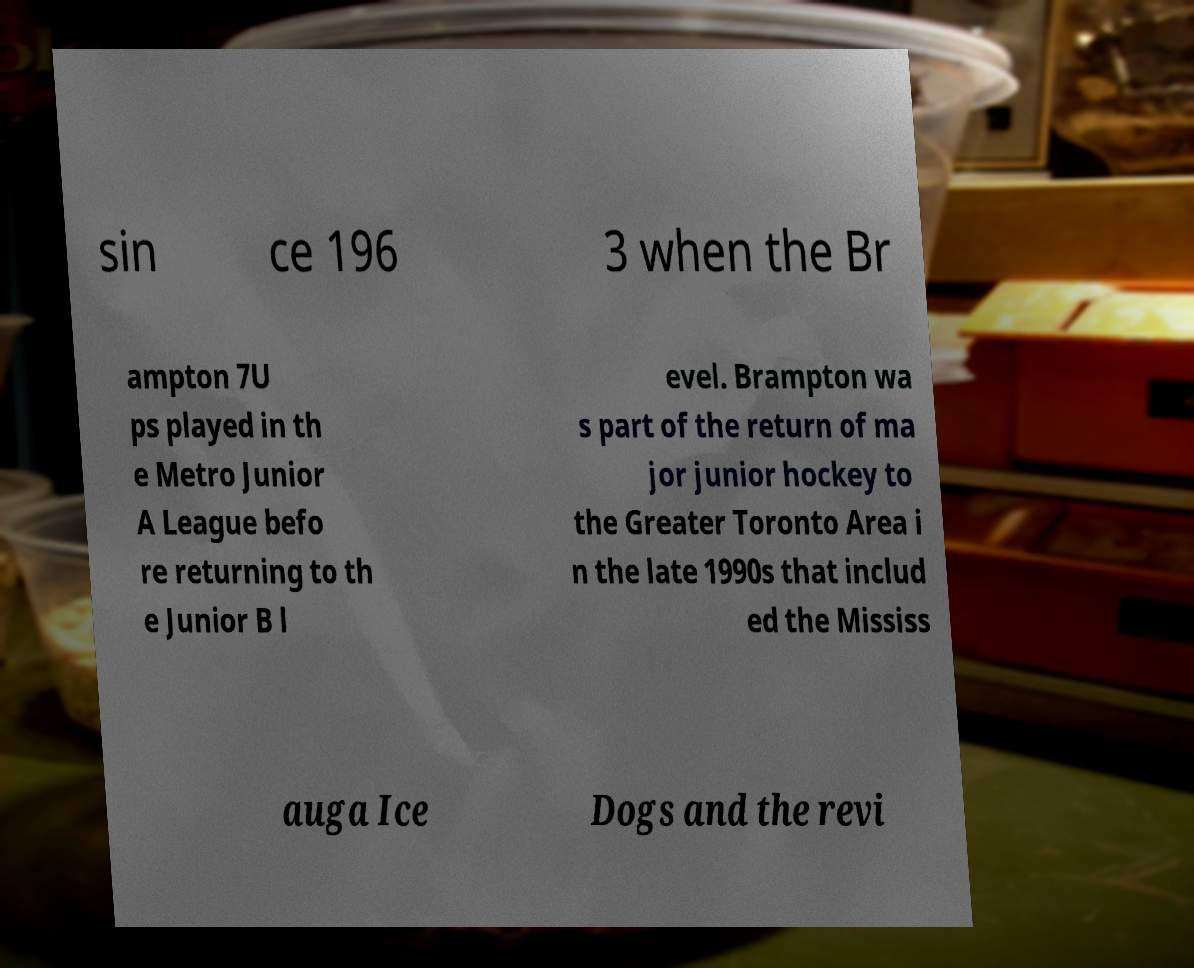I need the written content from this picture converted into text. Can you do that? sin ce 196 3 when the Br ampton 7U ps played in th e Metro Junior A League befo re returning to th e Junior B l evel. Brampton wa s part of the return of ma jor junior hockey to the Greater Toronto Area i n the late 1990s that includ ed the Mississ auga Ice Dogs and the revi 